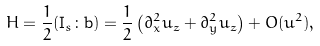<formula> <loc_0><loc_0><loc_500><loc_500>H = \frac { 1 } { 2 } ( \mathbf I _ { s } \colon \mathbf b ) = \frac { 1 } { 2 } \left ( \partial _ { x } ^ { 2 } u _ { z } + \partial _ { y } ^ { 2 } u _ { z } \right ) + O ( u ^ { 2 } ) ,</formula> 